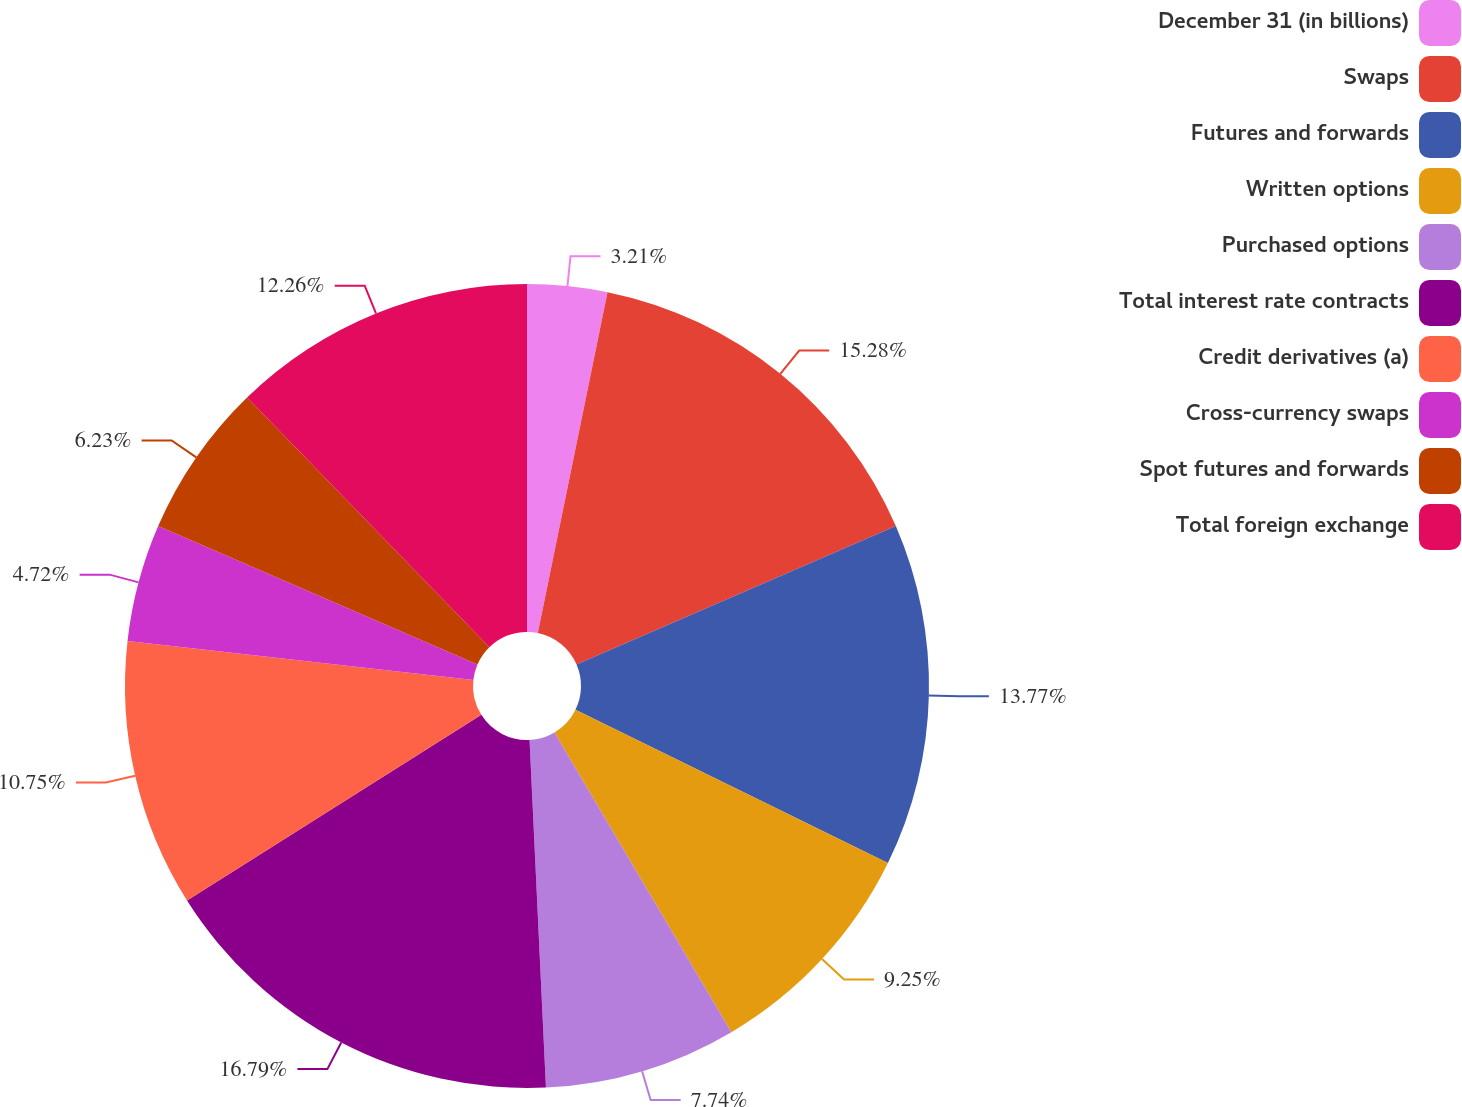Convert chart to OTSL. <chart><loc_0><loc_0><loc_500><loc_500><pie_chart><fcel>December 31 (in billions)<fcel>Swaps<fcel>Futures and forwards<fcel>Written options<fcel>Purchased options<fcel>Total interest rate contracts<fcel>Credit derivatives (a)<fcel>Cross-currency swaps<fcel>Spot futures and forwards<fcel>Total foreign exchange<nl><fcel>3.21%<fcel>15.28%<fcel>13.77%<fcel>9.25%<fcel>7.74%<fcel>16.79%<fcel>10.75%<fcel>4.72%<fcel>6.23%<fcel>12.26%<nl></chart> 